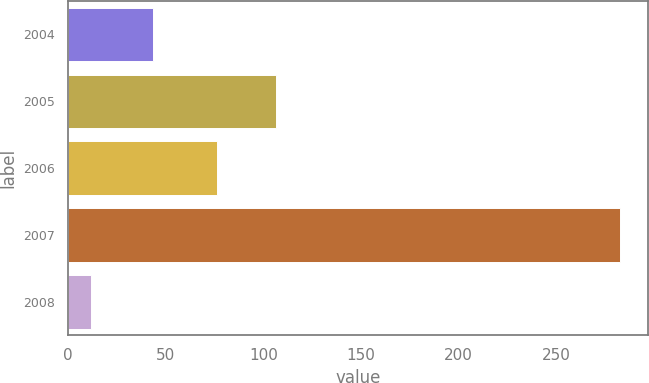Convert chart to OTSL. <chart><loc_0><loc_0><loc_500><loc_500><bar_chart><fcel>2004<fcel>2005<fcel>2006<fcel>2007<fcel>2008<nl><fcel>43.2<fcel>106.4<fcel>76.3<fcel>282.8<fcel>11.5<nl></chart> 